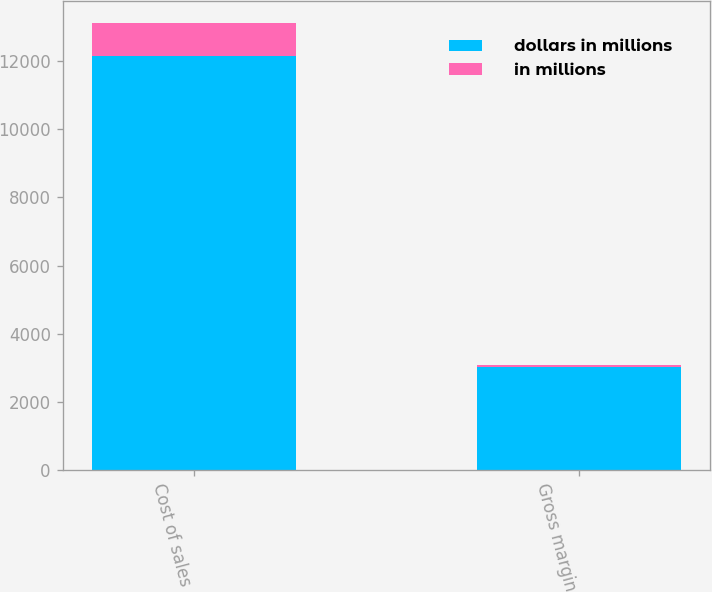<chart> <loc_0><loc_0><loc_500><loc_500><stacked_bar_chart><ecel><fcel>Cost of sales<fcel>Gross margin<nl><fcel>dollars in millions<fcel>12155<fcel>3010<nl><fcel>in millions<fcel>956<fcel>56<nl></chart> 